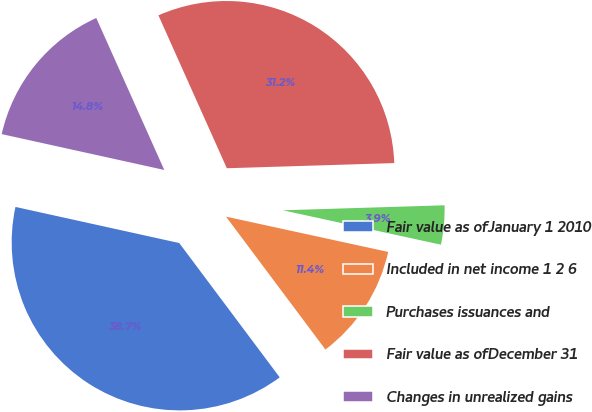<chart> <loc_0><loc_0><loc_500><loc_500><pie_chart><fcel>Fair value as ofJanuary 1 2010<fcel>Included in net income 1 2 6<fcel>Purchases issuances and<fcel>Fair value as ofDecember 31<fcel>Changes in unrealized gains<nl><fcel>38.68%<fcel>11.37%<fcel>3.9%<fcel>31.21%<fcel>14.85%<nl></chart> 